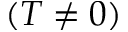<formula> <loc_0><loc_0><loc_500><loc_500>( T \neq 0 )</formula> 